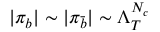<formula> <loc_0><loc_0><loc_500><loc_500>| \pi _ { b } | \sim | \pi _ { \bar { b } } | \sim \Lambda _ { T } ^ { N _ { c } }</formula> 